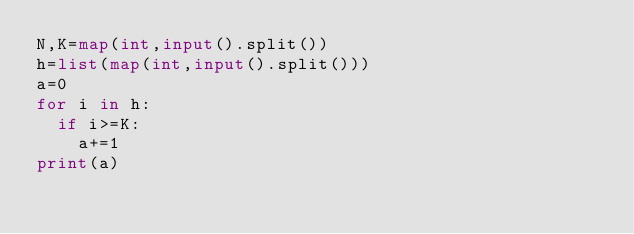Convert code to text. <code><loc_0><loc_0><loc_500><loc_500><_Python_>N,K=map(int,input().split())
h=list(map(int,input().split()))
a=0
for i in h:
  if i>=K:
    a+=1
print(a)</code> 